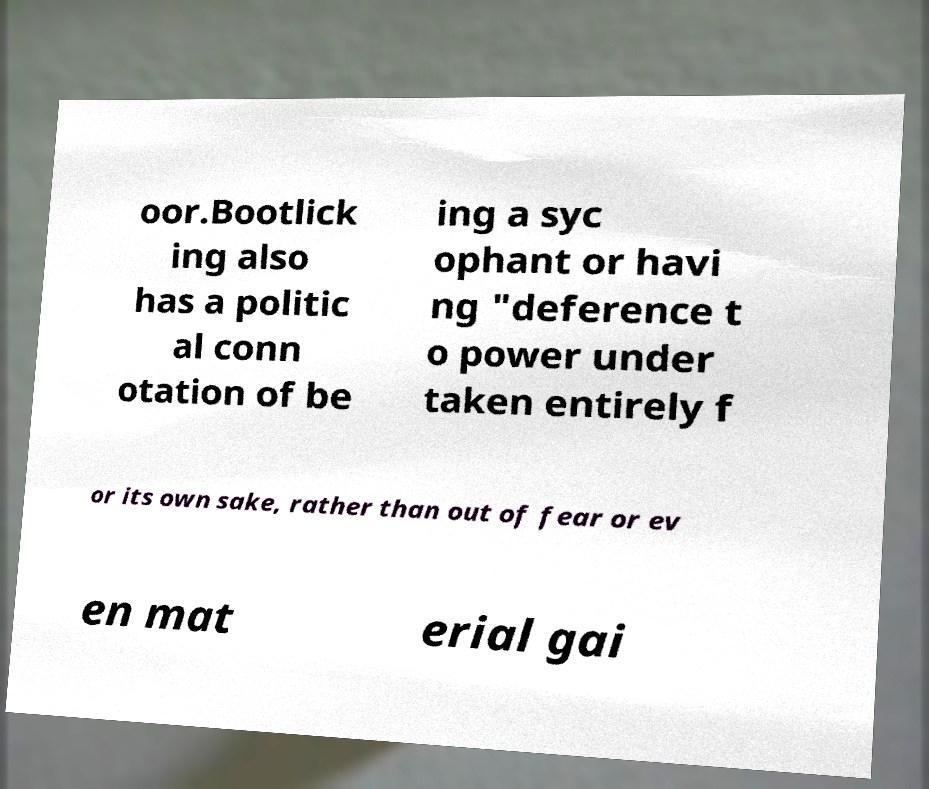For documentation purposes, I need the text within this image transcribed. Could you provide that? oor.Bootlick ing also has a politic al conn otation of be ing a syc ophant or havi ng "deference t o power under taken entirely f or its own sake, rather than out of fear or ev en mat erial gai 